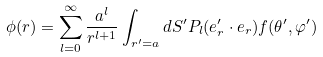Convert formula to latex. <formula><loc_0><loc_0><loc_500><loc_500>\phi ( { r } ) = \sum _ { l = 0 } ^ { \infty } \frac { a ^ { l } } { r ^ { l + 1 } } \int _ { r ^ { \prime } = a } d S ^ { \prime } P _ { l } ( { e } _ { r } ^ { \prime } \cdot { e } _ { r } ) f ( \theta ^ { \prime } , \varphi ^ { \prime } )</formula> 